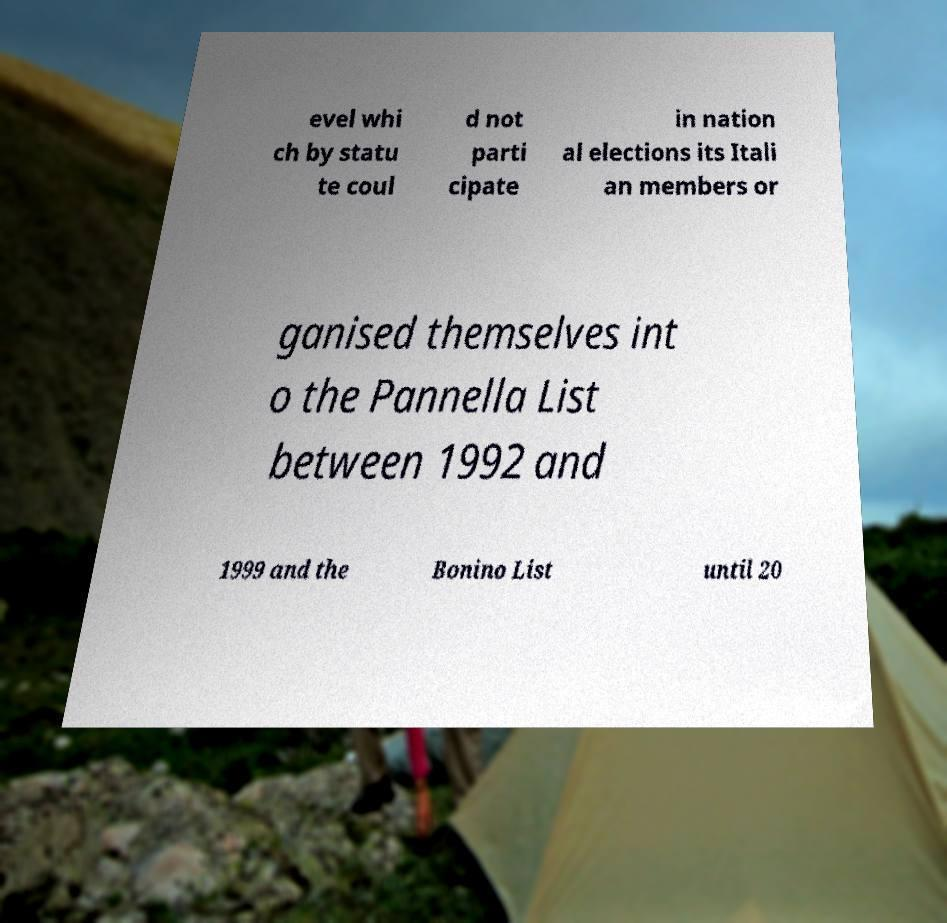Can you read and provide the text displayed in the image?This photo seems to have some interesting text. Can you extract and type it out for me? evel whi ch by statu te coul d not parti cipate in nation al elections its Itali an members or ganised themselves int o the Pannella List between 1992 and 1999 and the Bonino List until 20 